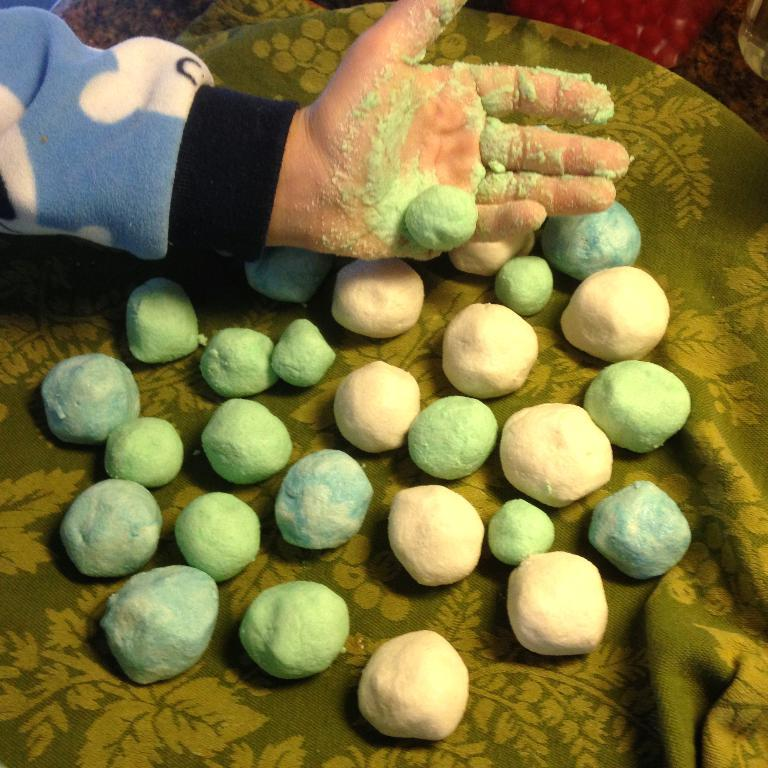What colors are present in the objects in the image? There are objects in white, green, and blue colors in the image. Can you describe the objects in each color? Unfortunately, the facts provided do not give specific details about the objects in each color. Where is the hand of a person located in the image? The hand of a person is located in the left top corner of the image. What type of parcel is being delivered by the judge in the image? There is no parcel or judge present in the image. Can you tell me the expertise of the expert in the image? There is no expert present in the image. 